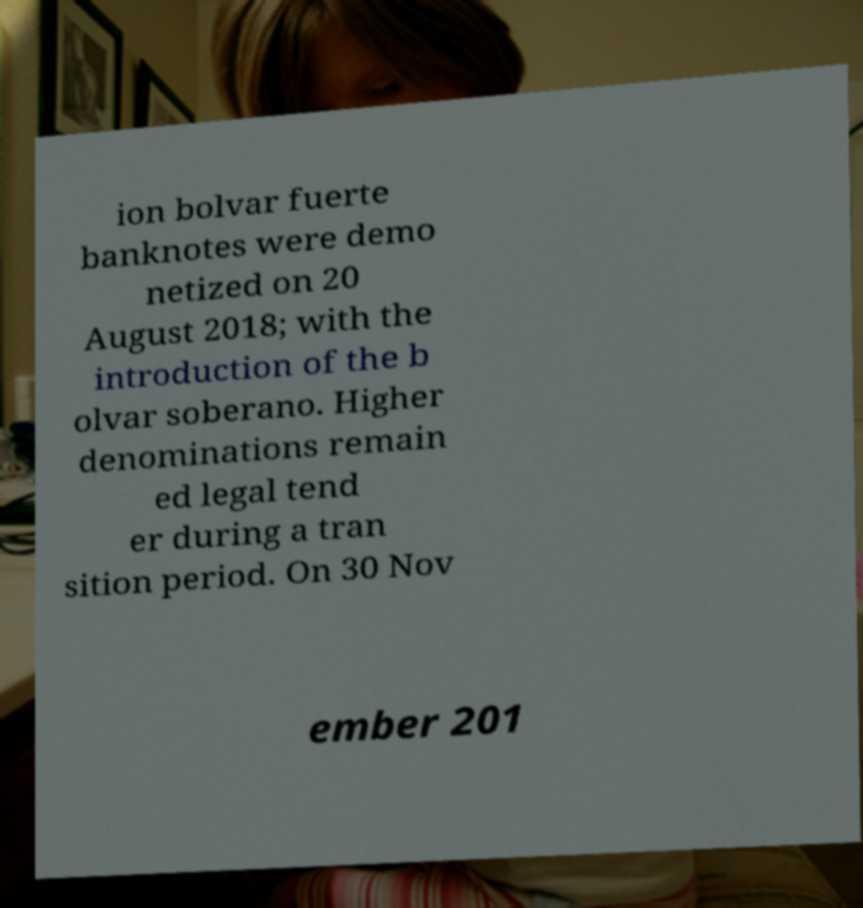For documentation purposes, I need the text within this image transcribed. Could you provide that? ion bolvar fuerte banknotes were demo netized on 20 August 2018; with the introduction of the b olvar soberano. Higher denominations remain ed legal tend er during a tran sition period. On 30 Nov ember 201 